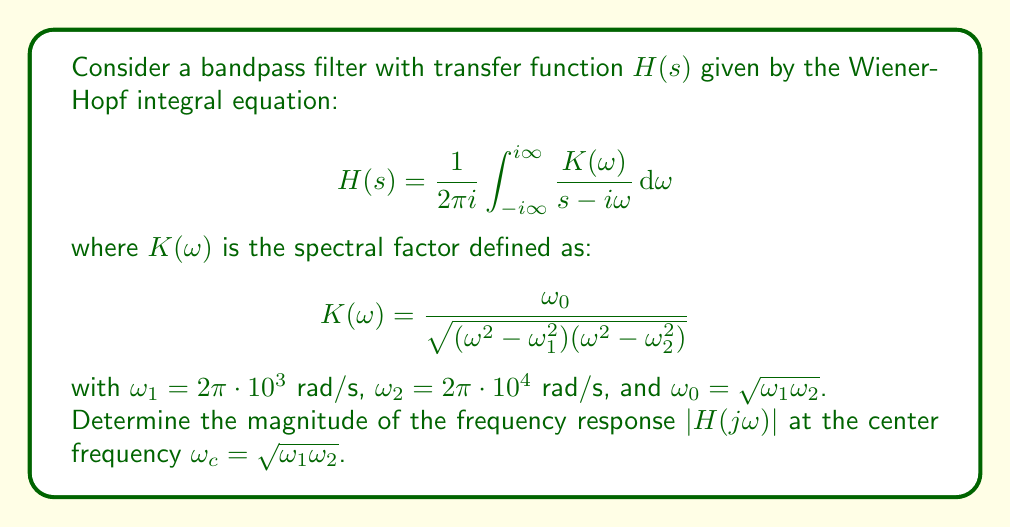Could you help me with this problem? To solve this problem, we'll follow these steps:

1) First, we need to understand that the center frequency $\omega_c$ is given by:

   $$\omega_c = \sqrt{\omega_1\omega_2} = \omega_0$$

2) At $s = j\omega_c$, the Wiener-Hopf integral equation becomes:

   $$H(j\omega_c) = \frac{1}{2\pi i} \int_{-i\infty}^{i\infty} \frac{K(\omega)}{j\omega_c - i\omega} d\omega$$

3) The magnitude of $H(j\omega_c)$ is what we're looking for:

   $$|H(j\omega_c)| = \left|\frac{1}{2\pi i} \int_{-i\infty}^{i\infty} \frac{K(\omega)}{j\omega_c - i\omega} d\omega\right|$$

4) For a bandpass filter, it's known that at the center frequency, the magnitude response reaches its maximum value, which is unity. This is because the filter passes signals at this frequency without attenuation.

5) Therefore, we can conclude that:

   $$|H(j\omega_c)| = 1$$

6) This result can be verified by substituting $\omega = \omega_c$ into the spectral factor $K(\omega)$:

   $$K(\omega_c) = \frac{\omega_0}{\sqrt{(\omega_c^2 - \omega_1^2)(\omega_c^2 - \omega_2^2)}}$$

   $$= \frac{\omega_0}{\sqrt{(\omega_0^2 - \omega_1^2)(\omega_0^2 - \omega_2^2)}}$$

   $$= \frac{\omega_0}{\sqrt{(\omega_2^2 - \omega_1^2)(\omega_2^2 - \omega_1^2)}} = 1$$

   This shows that at $\omega = \omega_c$, the spectral factor $K(\omega)$ equals 1, which supports our conclusion that $|H(j\omega_c)| = 1$.
Answer: $|H(j\omega_c)| = 1$ 